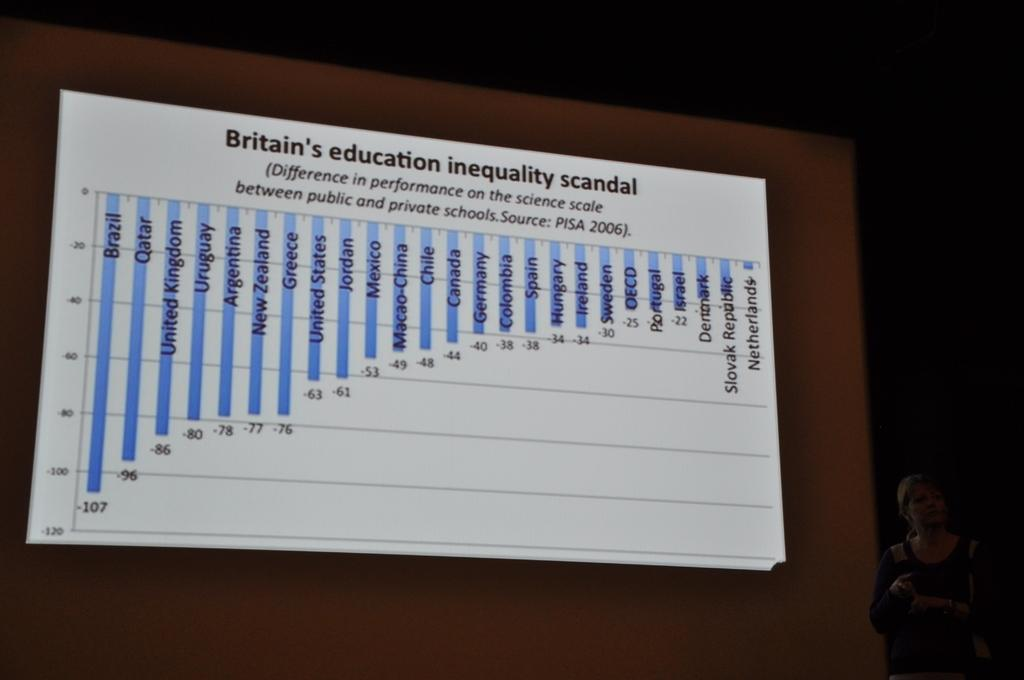What is being displayed on the screen in the image? There is a screen displaying statistics in the image. Can you describe the person in the image? There is a person in the bottom right corner of the image. What type of comb is the secretary using in the image? There is no comb or secretary present in the image. What stage of development is the project in, as shown in the image? The image does not show any project or development; it only displays statistics on a screen and a person in the bottom right corner. 